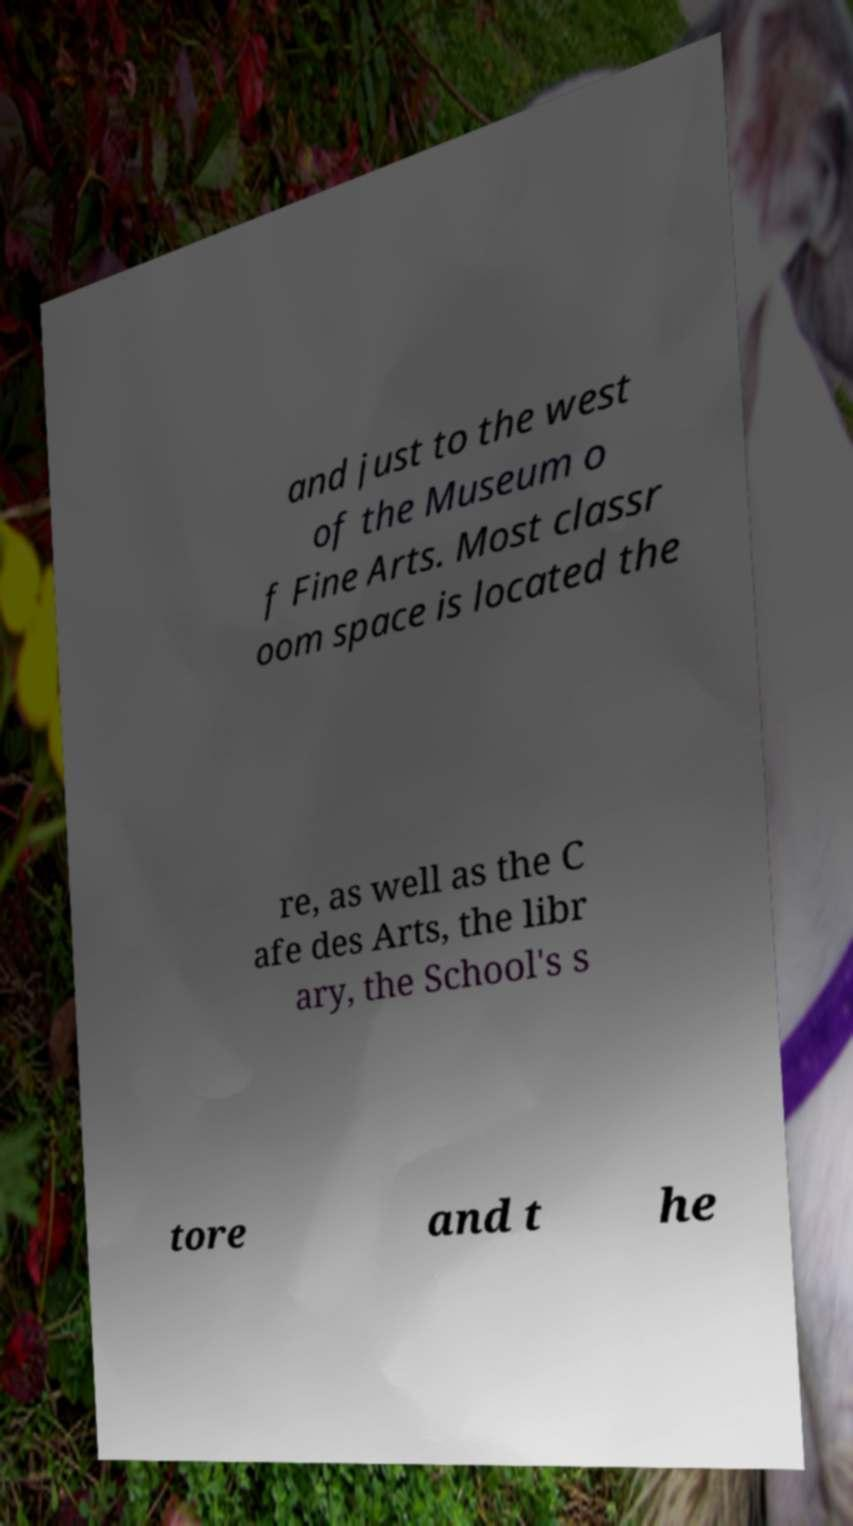There's text embedded in this image that I need extracted. Can you transcribe it verbatim? and just to the west of the Museum o f Fine Arts. Most classr oom space is located the re, as well as the C afe des Arts, the libr ary, the School's s tore and t he 